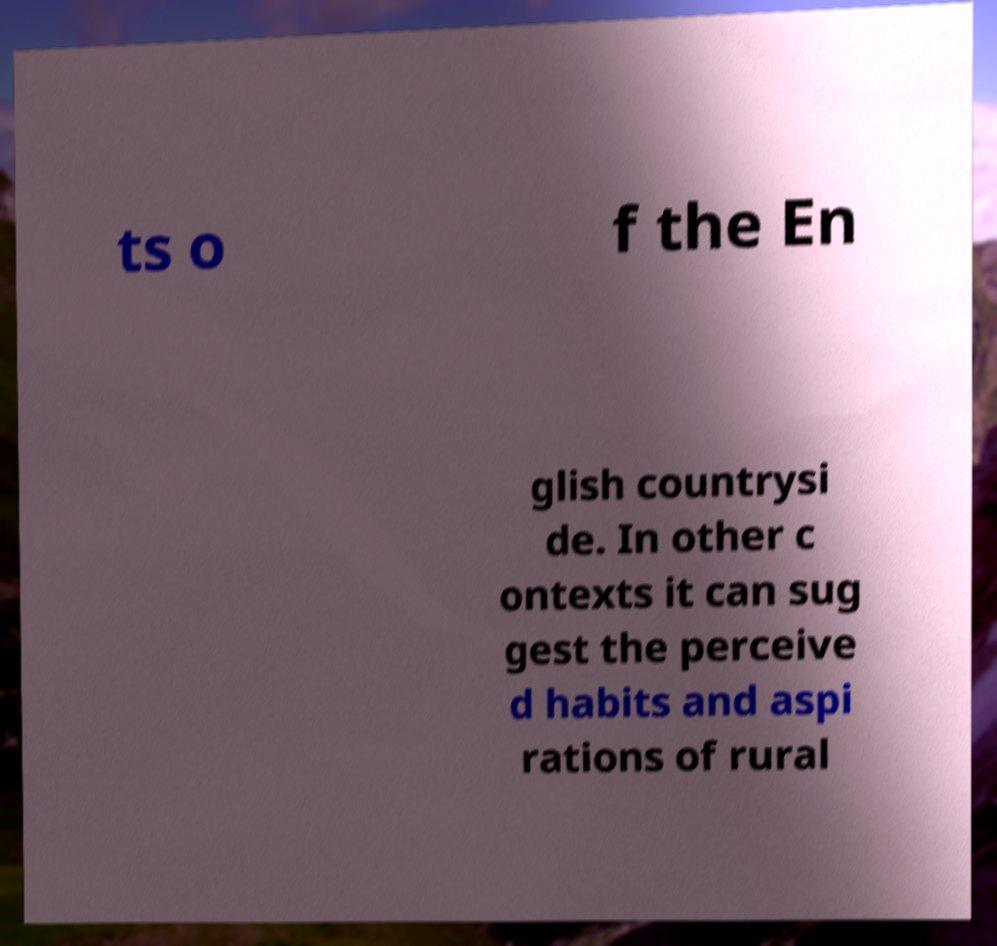Could you extract and type out the text from this image? ts o f the En glish countrysi de. In other c ontexts it can sug gest the perceive d habits and aspi rations of rural 